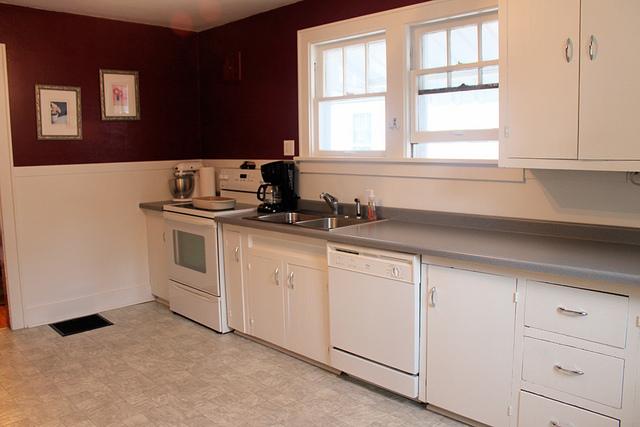How do the windows open?
Concise answer only. Up. Is this indoors?
Give a very brief answer. Yes. Is this kitchen clean?
Be succinct. Yes. What is covering the window?
Answer briefly. Nothing. Where is the framed photo?
Keep it brief. On wall. Are the blinds open or closed?
Be succinct. Open. What color is the frame on the back wall?
Write a very short answer. Gold. 